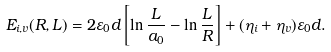<formula> <loc_0><loc_0><loc_500><loc_500>E _ { i , v } ( R , L ) = 2 \varepsilon _ { 0 } d \left [ \ln \frac { L } { a _ { 0 } } - \ln \frac { L } { R } \right ] + ( \eta _ { i } + \eta _ { v } ) \varepsilon _ { 0 } d .</formula> 